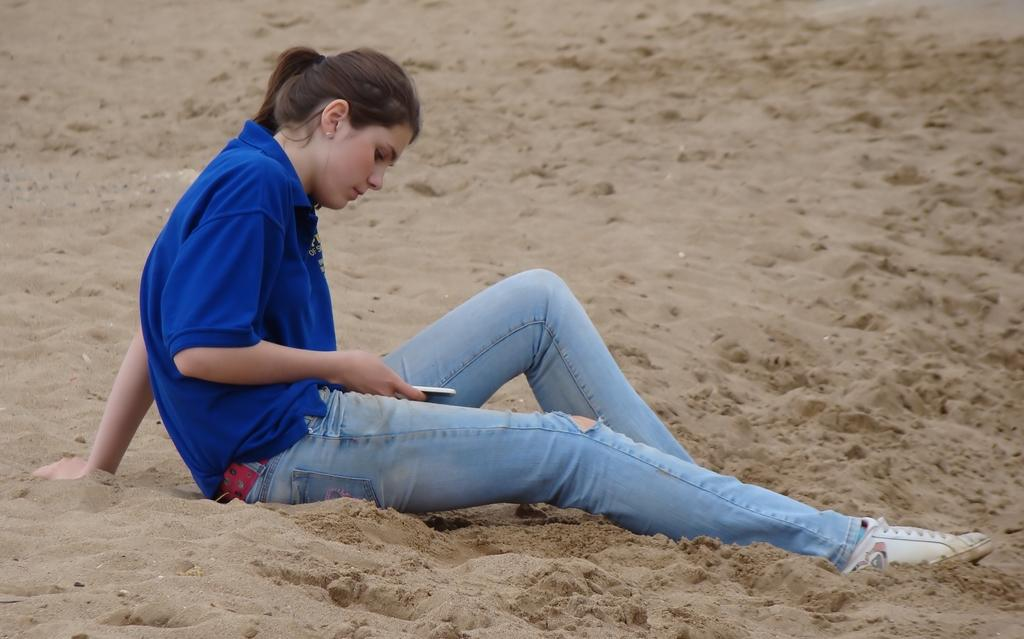Who is the main subject in the image? There is a woman in the image. What is the woman doing in the image? The woman is sitting on the sand and operating a mobile phone. What type of clothing is the woman wearing? The woman is wearing jeans and a blue shirt. Can you tell me how many icicles are hanging from the woman's shirt in the image? There are no icicles present in the image; the woman is wearing a blue shirt. Is the woman's grandfather sitting next to her in the image? There is no mention of a grandfather or any other person in the image; it only features the woman. 